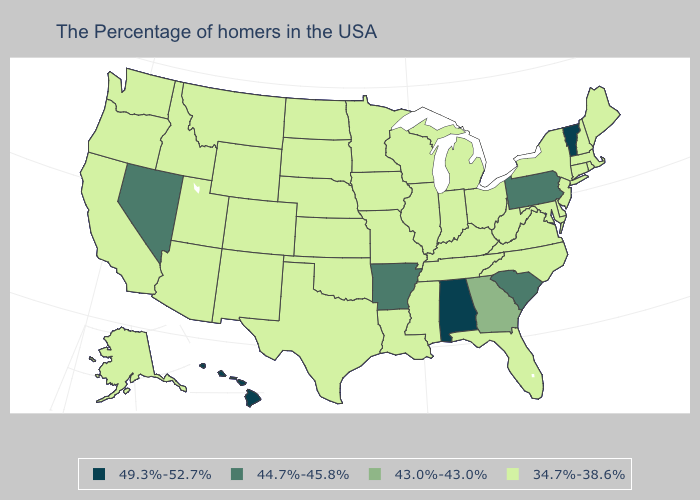Name the states that have a value in the range 34.7%-38.6%?
Short answer required. Maine, Massachusetts, Rhode Island, New Hampshire, Connecticut, New York, New Jersey, Delaware, Maryland, Virginia, North Carolina, West Virginia, Ohio, Florida, Michigan, Kentucky, Indiana, Tennessee, Wisconsin, Illinois, Mississippi, Louisiana, Missouri, Minnesota, Iowa, Kansas, Nebraska, Oklahoma, Texas, South Dakota, North Dakota, Wyoming, Colorado, New Mexico, Utah, Montana, Arizona, Idaho, California, Washington, Oregon, Alaska. Does Vermont have the highest value in the Northeast?
Give a very brief answer. Yes. Which states hav the highest value in the South?
Write a very short answer. Alabama. Does Oregon have the lowest value in the West?
Quick response, please. Yes. Name the states that have a value in the range 49.3%-52.7%?
Keep it brief. Vermont, Alabama, Hawaii. What is the value of Michigan?
Give a very brief answer. 34.7%-38.6%. What is the value of Alaska?
Answer briefly. 34.7%-38.6%. Name the states that have a value in the range 43.0%-43.0%?
Keep it brief. Georgia. Name the states that have a value in the range 34.7%-38.6%?
Concise answer only. Maine, Massachusetts, Rhode Island, New Hampshire, Connecticut, New York, New Jersey, Delaware, Maryland, Virginia, North Carolina, West Virginia, Ohio, Florida, Michigan, Kentucky, Indiana, Tennessee, Wisconsin, Illinois, Mississippi, Louisiana, Missouri, Minnesota, Iowa, Kansas, Nebraska, Oklahoma, Texas, South Dakota, North Dakota, Wyoming, Colorado, New Mexico, Utah, Montana, Arizona, Idaho, California, Washington, Oregon, Alaska. What is the value of Montana?
Answer briefly. 34.7%-38.6%. Does Louisiana have the highest value in the USA?
Quick response, please. No. Does the map have missing data?
Give a very brief answer. No. Which states have the lowest value in the MidWest?
Quick response, please. Ohio, Michigan, Indiana, Wisconsin, Illinois, Missouri, Minnesota, Iowa, Kansas, Nebraska, South Dakota, North Dakota. Name the states that have a value in the range 44.7%-45.8%?
Quick response, please. Pennsylvania, South Carolina, Arkansas, Nevada. 